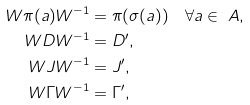<formula> <loc_0><loc_0><loc_500><loc_500>W \pi ( a ) W ^ { - 1 } & = \pi ( \sigma ( a ) ) \quad \forall a \in \ A , \\ W D W ^ { - 1 } & = D ^ { \prime } , \\ W J W ^ { - 1 } & = J ^ { \prime } , \\ W \Gamma W ^ { - 1 } & = \Gamma ^ { \prime } ,</formula> 